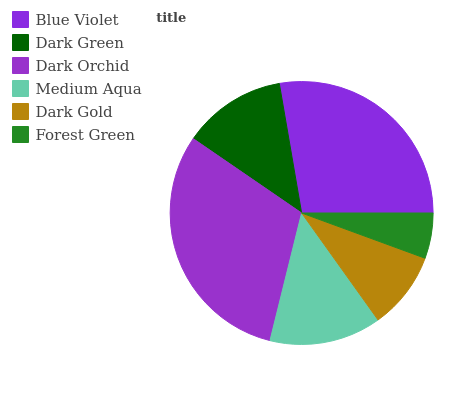Is Forest Green the minimum?
Answer yes or no. Yes. Is Dark Orchid the maximum?
Answer yes or no. Yes. Is Dark Green the minimum?
Answer yes or no. No. Is Dark Green the maximum?
Answer yes or no. No. Is Blue Violet greater than Dark Green?
Answer yes or no. Yes. Is Dark Green less than Blue Violet?
Answer yes or no. Yes. Is Dark Green greater than Blue Violet?
Answer yes or no. No. Is Blue Violet less than Dark Green?
Answer yes or no. No. Is Medium Aqua the high median?
Answer yes or no. Yes. Is Dark Green the low median?
Answer yes or no. Yes. Is Dark Orchid the high median?
Answer yes or no. No. Is Blue Violet the low median?
Answer yes or no. No. 